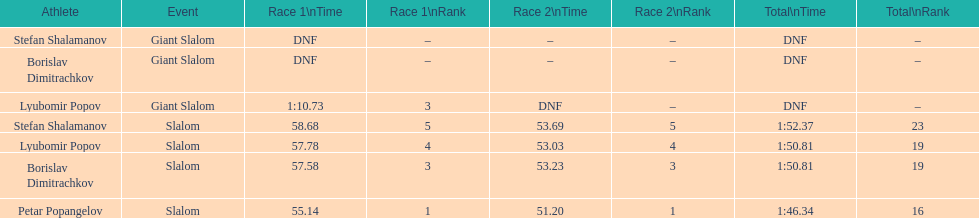What is the number of athletes to finish race one in the giant slalom? 1. 